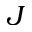<formula> <loc_0><loc_0><loc_500><loc_500>J</formula> 